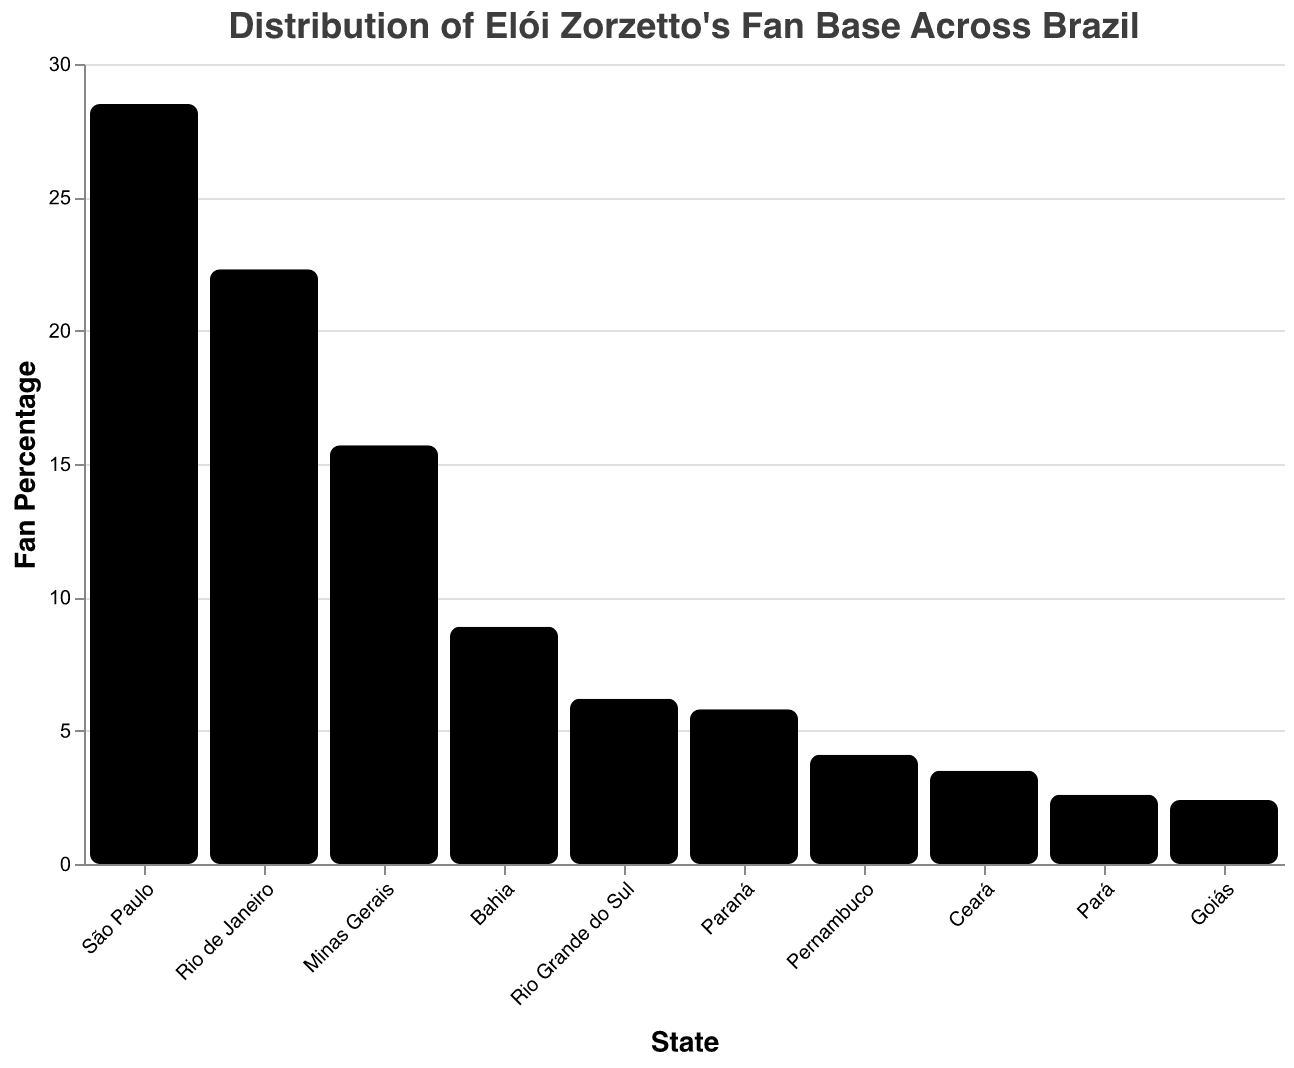How many states are displayed in the figure? First, identify the states listed under the "State" field in the figure. Count the number of unique states.
Answer: 10 Which state has the highest percentage of fans? Look for the bar with the highest value on the y-axis, which represents the fan percentage. The corresponding state on the x-axis is the one with the highest percentage.
Answer: São Paulo What is the combined percentage of fans in São Paulo and Rio de Janeiro? Find the fan percentages for São Paulo and Rio de Janeiro, which are 28.5% and 22.3%, respectively. Add these two percentages together to get the combined percentage.
Answer: 50.8% Which state has a lower percentage of fans, Paraná or Rio Grande do Sul? Compare the fan percentages of Paraná (5.8%) and Rio Grande do Sul (6.2%). The state with the lower percentage is the answer.
Answer: Paraná What is the total fan percentage for the states of Bahia, Pernambuco, and Ceará? Find the fan percentages for Bahia (8.9%), Pernambuco (4.1%), and Ceará (3.5%). Add these percentages together to get the total fan percentage.
Answer: 16.5% How much higher is the fan percentage in Minas Gerais compared to Goiás? Find the fan percentages for Minas Gerais (15.7%) and Goiás (2.4%). Subtract the percentage of Goiás from Minas Gerais.
Answer: 13.3% Which region in Brazil has the highest concentration of fans based on the figure? Assess the states listed and their corresponding fan percentages. Given that São Paulo and Rio de Janeiro have the highest percentages and are located in the Southeast region, this region has the highest concentration.
Answer: Southeast What is the average fan percentage across all states displayed in the figure? Sum all the fan percentages: 28.5 + 22.3 + 15.7 + 8.9 + 6.2 + 5.8 + 4.1 + 3.5 + 2.6 + 2.4 = 100. Then, divide by the number of states (10).
Answer: 10% Which state has a higher percentage of fans, Pará or Ceará? Compare the fan percentages of Pará (2.6%) and Ceará (3.5%). The state with the higher percentage is the answer.
Answer: Ceará 